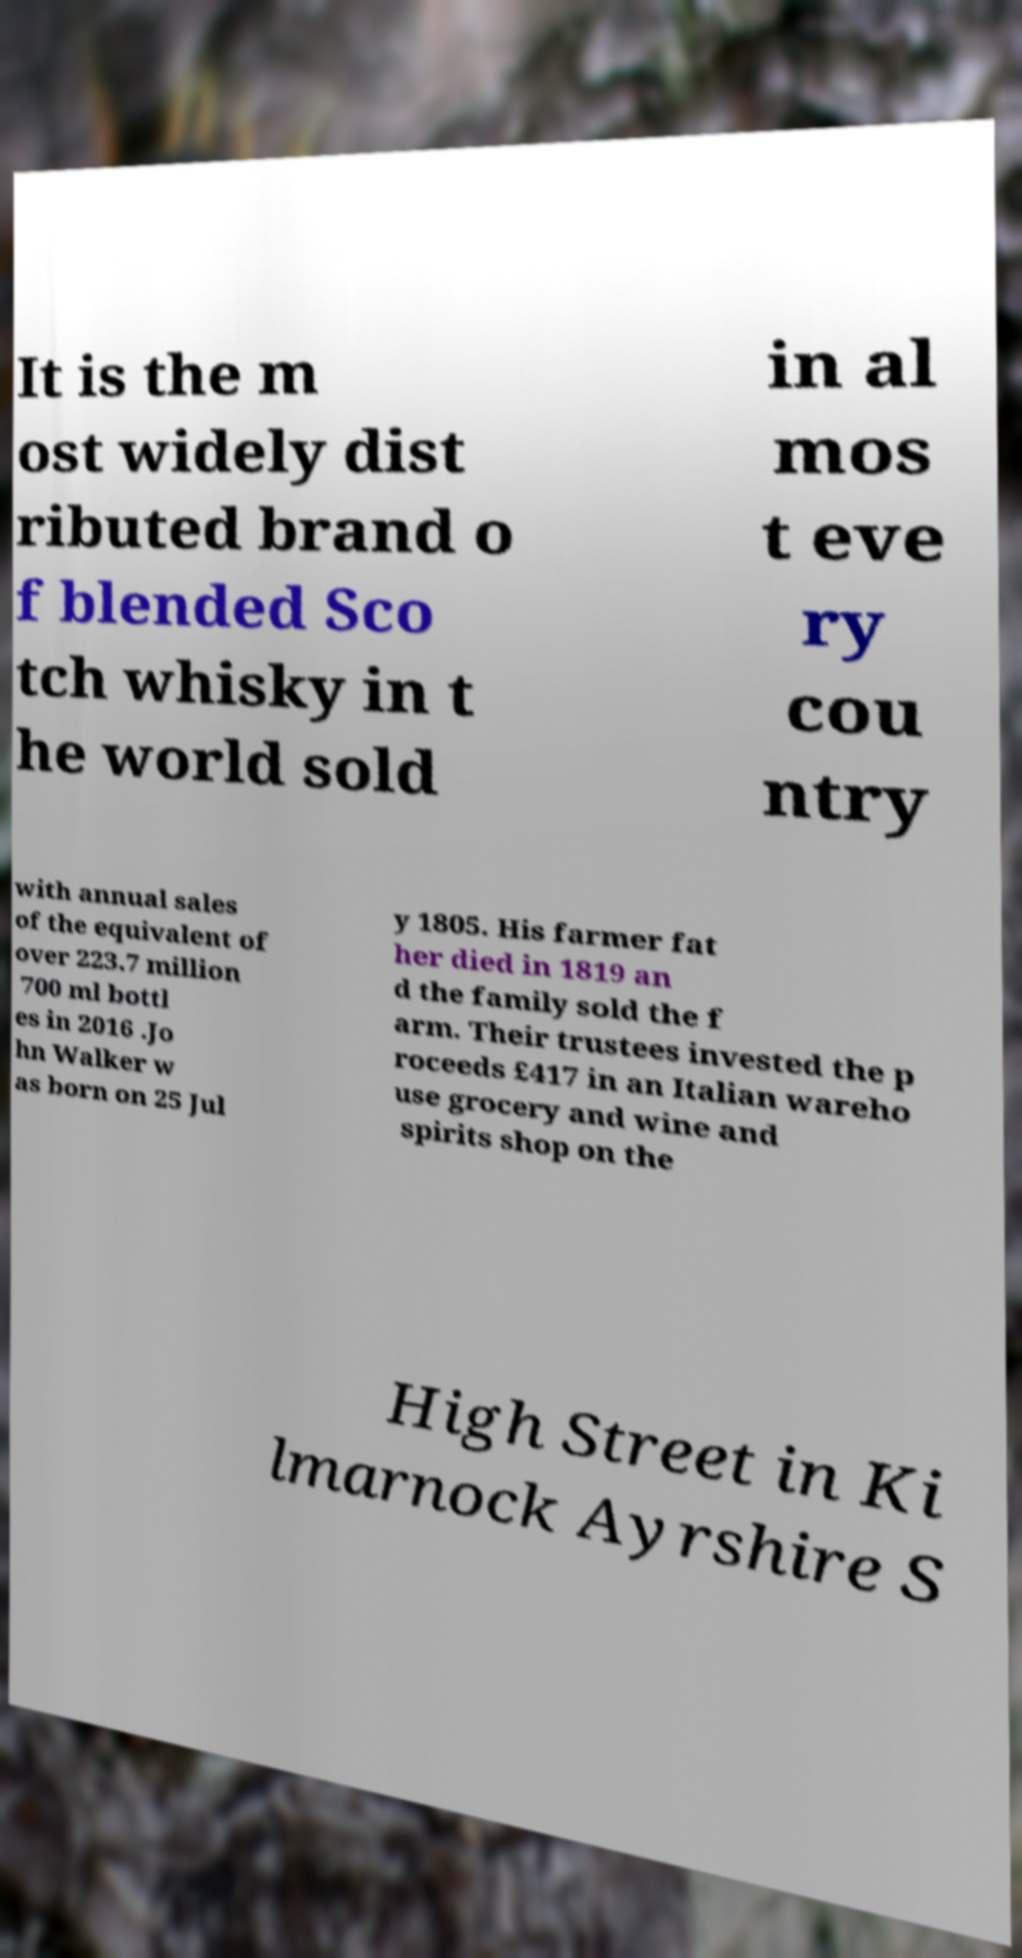Could you extract and type out the text from this image? It is the m ost widely dist ributed brand o f blended Sco tch whisky in t he world sold in al mos t eve ry cou ntry with annual sales of the equivalent of over 223.7 million 700 ml bottl es in 2016 .Jo hn Walker w as born on 25 Jul y 1805. His farmer fat her died in 1819 an d the family sold the f arm. Their trustees invested the p roceeds £417 in an Italian wareho use grocery and wine and spirits shop on the High Street in Ki lmarnock Ayrshire S 